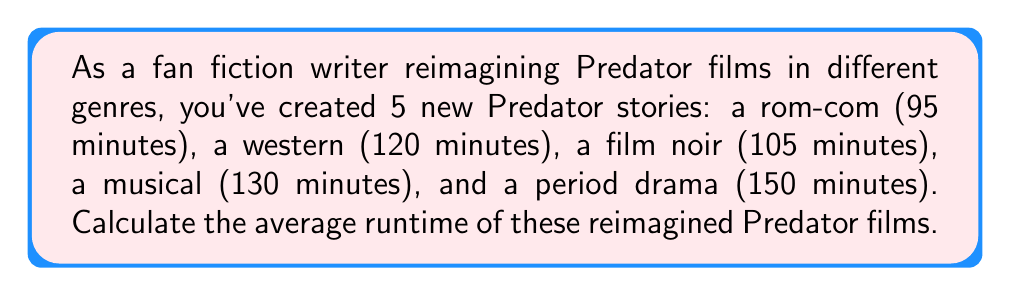Provide a solution to this math problem. To calculate the average runtime, we need to:

1. Sum up all the runtimes:
   $95 + 120 + 105 + 130 + 150 = 600$ minutes

2. Count the total number of films:
   There are 5 films in total.

3. Divide the sum by the number of films:
   $\text{Average} = \frac{\text{Sum of runtimes}}{\text{Number of films}}$

   $\text{Average} = \frac{600}{5} = 120$ minutes

Therefore, the average runtime of the reimagined Predator films across various genres is 120 minutes.
Answer: 120 minutes 